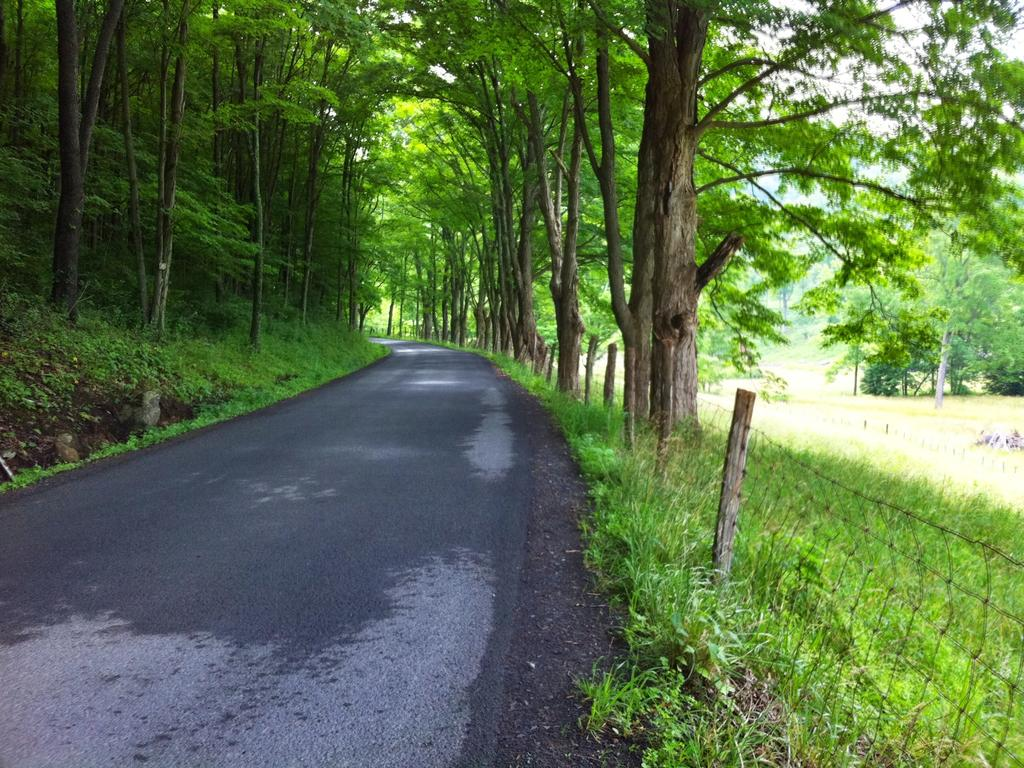What is the main feature of the image? There is a road in the image. What can be seen alongside the road? There are many trees on either side of the road in the image. What type of barrier is present in the image? There is a wired fence in the image. What is the ground surface like in the image? Grass is visible in the image. What type of fowl can be seen flying over the road in the image? There are no fowl visible in the image; it only shows a road, trees, a wired fence, and grass. 